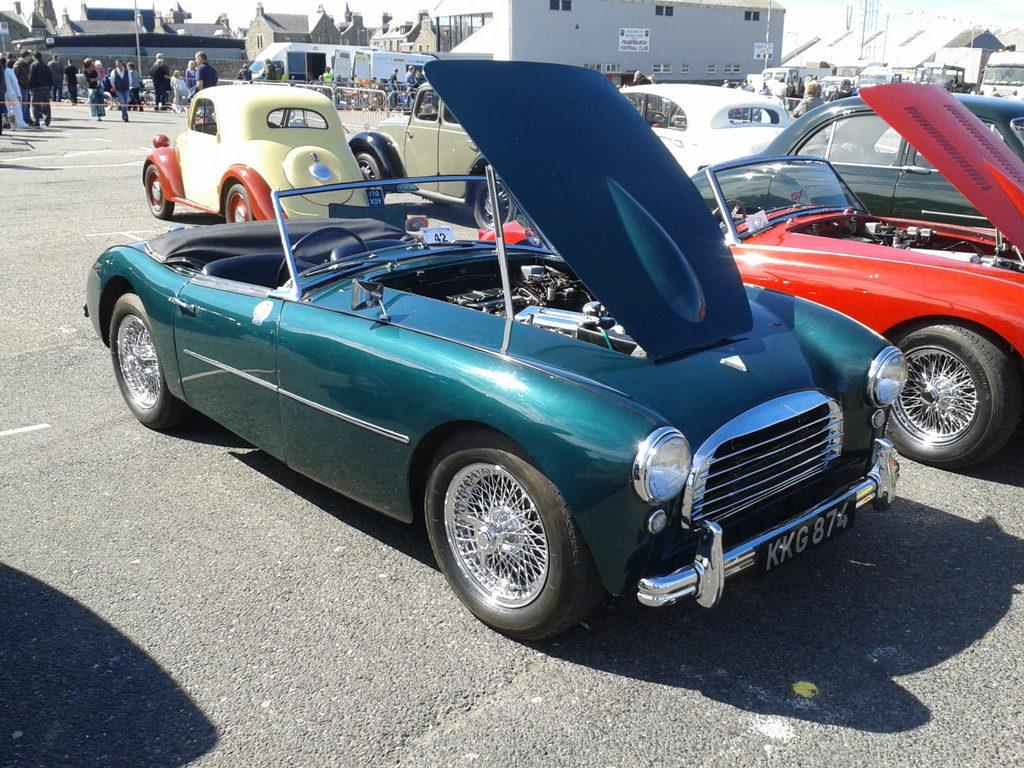What is the main subject in the foreground of the image? There is a car with an open bonnet on the ground in the foreground. What can be seen in the background of the image? There are cars, buildings, poles, and persons standing in the background. What type of loaf is being used as a replacement part for the car in the image? There is no loaf present in the image, and it is not being used as a replacement part for the car. 